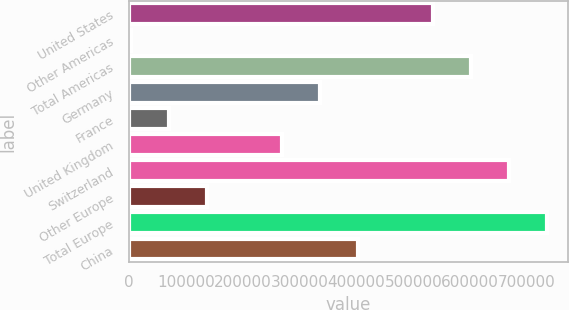Convert chart to OTSL. <chart><loc_0><loc_0><loc_500><loc_500><bar_chart><fcel>United States<fcel>Other Americas<fcel>Total Americas<fcel>Germany<fcel>France<fcel>United Kingdom<fcel>Switzerland<fcel>Other Europe<fcel>Total Europe<fcel>China<nl><fcel>535298<fcel>3406<fcel>601784<fcel>335838<fcel>69892.5<fcel>269352<fcel>668271<fcel>136379<fcel>734758<fcel>402325<nl></chart> 